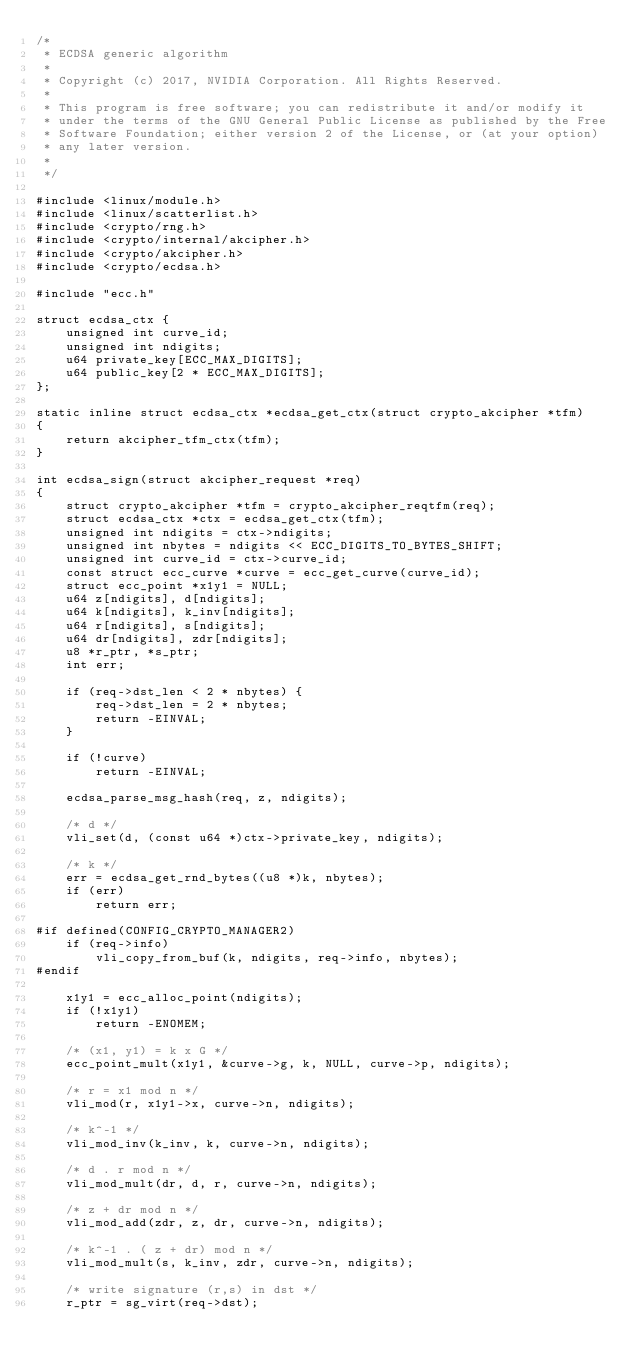Convert code to text. <code><loc_0><loc_0><loc_500><loc_500><_C_>/*
 * ECDSA generic algorithm
 *
 * Copyright (c) 2017, NVIDIA Corporation. All Rights Reserved.
 *
 * This program is free software; you can redistribute it and/or modify it
 * under the terms of the GNU General Public License as published by the Free
 * Software Foundation; either version 2 of the License, or (at your option)
 * any later version.
 *
 */

#include <linux/module.h>
#include <linux/scatterlist.h>
#include <crypto/rng.h>
#include <crypto/internal/akcipher.h>
#include <crypto/akcipher.h>
#include <crypto/ecdsa.h>

#include "ecc.h"

struct ecdsa_ctx {
	unsigned int curve_id;
	unsigned int ndigits;
	u64 private_key[ECC_MAX_DIGITS];
	u64 public_key[2 * ECC_MAX_DIGITS];
};

static inline struct ecdsa_ctx *ecdsa_get_ctx(struct crypto_akcipher *tfm)
{
	return akcipher_tfm_ctx(tfm);
}

int ecdsa_sign(struct akcipher_request *req)
{
	struct crypto_akcipher *tfm = crypto_akcipher_reqtfm(req);
	struct ecdsa_ctx *ctx = ecdsa_get_ctx(tfm);
	unsigned int ndigits = ctx->ndigits;
	unsigned int nbytes = ndigits << ECC_DIGITS_TO_BYTES_SHIFT;
	unsigned int curve_id = ctx->curve_id;
	const struct ecc_curve *curve = ecc_get_curve(curve_id);
	struct ecc_point *x1y1 = NULL;
	u64 z[ndigits], d[ndigits];
	u64 k[ndigits], k_inv[ndigits];
	u64 r[ndigits], s[ndigits];
	u64 dr[ndigits], zdr[ndigits];
	u8 *r_ptr, *s_ptr;
	int err;

	if (req->dst_len < 2 * nbytes) {
		req->dst_len = 2 * nbytes;
		return -EINVAL;
	}

	if (!curve)
		return -EINVAL;

	ecdsa_parse_msg_hash(req, z, ndigits);

	/* d */
	vli_set(d, (const u64 *)ctx->private_key, ndigits);

	/* k */
	err = ecdsa_get_rnd_bytes((u8 *)k, nbytes);
	if (err)
		return err;

#if defined(CONFIG_CRYPTO_MANAGER2)
	if (req->info)
		vli_copy_from_buf(k, ndigits, req->info, nbytes);
#endif

	x1y1 = ecc_alloc_point(ndigits);
	if (!x1y1)
		return -ENOMEM;

	/* (x1, y1) = k x G */
	ecc_point_mult(x1y1, &curve->g, k, NULL, curve->p, ndigits);

	/* r = x1 mod n */
	vli_mod(r, x1y1->x, curve->n, ndigits);

	/* k^-1 */
	vli_mod_inv(k_inv, k, curve->n, ndigits);

	/* d . r mod n */
	vli_mod_mult(dr, d, r, curve->n, ndigits);

	/* z + dr mod n */
	vli_mod_add(zdr, z, dr, curve->n, ndigits);

	/* k^-1 . ( z + dr) mod n */
	vli_mod_mult(s, k_inv, zdr, curve->n, ndigits);

	/* write signature (r,s) in dst */
	r_ptr = sg_virt(req->dst);</code> 